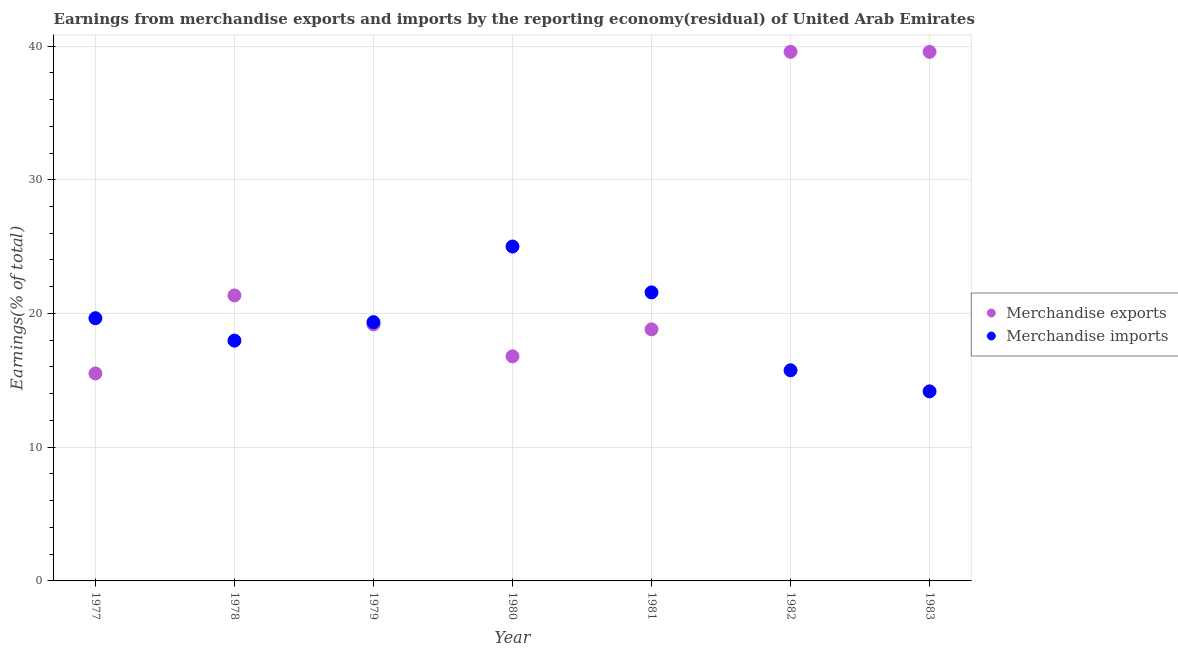How many different coloured dotlines are there?
Give a very brief answer. 2. What is the earnings from merchandise exports in 1981?
Make the answer very short. 18.81. Across all years, what is the maximum earnings from merchandise exports?
Offer a very short reply. 39.56. Across all years, what is the minimum earnings from merchandise exports?
Your answer should be compact. 15.52. In which year was the earnings from merchandise exports maximum?
Your answer should be very brief. 1982. In which year was the earnings from merchandise exports minimum?
Your answer should be very brief. 1977. What is the total earnings from merchandise imports in the graph?
Your answer should be very brief. 133.48. What is the difference between the earnings from merchandise imports in 1978 and that in 1983?
Your response must be concise. 3.79. What is the difference between the earnings from merchandise imports in 1982 and the earnings from merchandise exports in 1983?
Your answer should be very brief. -23.81. What is the average earnings from merchandise imports per year?
Make the answer very short. 19.07. In the year 1982, what is the difference between the earnings from merchandise exports and earnings from merchandise imports?
Your answer should be compact. 23.81. In how many years, is the earnings from merchandise imports greater than 20 %?
Offer a very short reply. 2. What is the ratio of the earnings from merchandise imports in 1978 to that in 1981?
Make the answer very short. 0.83. What is the difference between the highest and the second highest earnings from merchandise imports?
Your response must be concise. 3.43. What is the difference between the highest and the lowest earnings from merchandise exports?
Your response must be concise. 24.05. In how many years, is the earnings from merchandise exports greater than the average earnings from merchandise exports taken over all years?
Offer a very short reply. 2. Is the sum of the earnings from merchandise imports in 1977 and 1980 greater than the maximum earnings from merchandise exports across all years?
Offer a very short reply. Yes. Does the earnings from merchandise imports monotonically increase over the years?
Your answer should be very brief. No. How many years are there in the graph?
Your answer should be compact. 7. What is the difference between two consecutive major ticks on the Y-axis?
Offer a terse response. 10. Does the graph contain grids?
Provide a succinct answer. Yes. What is the title of the graph?
Offer a very short reply. Earnings from merchandise exports and imports by the reporting economy(residual) of United Arab Emirates. What is the label or title of the Y-axis?
Offer a terse response. Earnings(% of total). What is the Earnings(% of total) of Merchandise exports in 1977?
Keep it short and to the point. 15.52. What is the Earnings(% of total) of Merchandise imports in 1977?
Ensure brevity in your answer.  19.65. What is the Earnings(% of total) of Merchandise exports in 1978?
Make the answer very short. 21.35. What is the Earnings(% of total) in Merchandise imports in 1978?
Give a very brief answer. 17.97. What is the Earnings(% of total) of Merchandise exports in 1979?
Offer a terse response. 19.18. What is the Earnings(% of total) in Merchandise imports in 1979?
Provide a succinct answer. 19.35. What is the Earnings(% of total) in Merchandise exports in 1980?
Your answer should be very brief. 16.79. What is the Earnings(% of total) of Merchandise imports in 1980?
Keep it short and to the point. 25.01. What is the Earnings(% of total) of Merchandise exports in 1981?
Your response must be concise. 18.81. What is the Earnings(% of total) of Merchandise imports in 1981?
Offer a terse response. 21.58. What is the Earnings(% of total) of Merchandise exports in 1982?
Offer a very short reply. 39.56. What is the Earnings(% of total) in Merchandise imports in 1982?
Offer a terse response. 15.75. What is the Earnings(% of total) in Merchandise exports in 1983?
Provide a succinct answer. 39.56. What is the Earnings(% of total) in Merchandise imports in 1983?
Provide a short and direct response. 14.18. Across all years, what is the maximum Earnings(% of total) of Merchandise exports?
Provide a succinct answer. 39.56. Across all years, what is the maximum Earnings(% of total) in Merchandise imports?
Your response must be concise. 25.01. Across all years, what is the minimum Earnings(% of total) of Merchandise exports?
Give a very brief answer. 15.52. Across all years, what is the minimum Earnings(% of total) in Merchandise imports?
Offer a very short reply. 14.18. What is the total Earnings(% of total) in Merchandise exports in the graph?
Offer a terse response. 170.78. What is the total Earnings(% of total) of Merchandise imports in the graph?
Ensure brevity in your answer.  133.48. What is the difference between the Earnings(% of total) of Merchandise exports in 1977 and that in 1978?
Make the answer very short. -5.83. What is the difference between the Earnings(% of total) in Merchandise imports in 1977 and that in 1978?
Offer a terse response. 1.68. What is the difference between the Earnings(% of total) of Merchandise exports in 1977 and that in 1979?
Offer a very short reply. -3.67. What is the difference between the Earnings(% of total) in Merchandise imports in 1977 and that in 1979?
Make the answer very short. 0.29. What is the difference between the Earnings(% of total) of Merchandise exports in 1977 and that in 1980?
Your answer should be compact. -1.28. What is the difference between the Earnings(% of total) in Merchandise imports in 1977 and that in 1980?
Keep it short and to the point. -5.36. What is the difference between the Earnings(% of total) in Merchandise exports in 1977 and that in 1981?
Offer a terse response. -3.3. What is the difference between the Earnings(% of total) in Merchandise imports in 1977 and that in 1981?
Offer a very short reply. -1.93. What is the difference between the Earnings(% of total) of Merchandise exports in 1977 and that in 1982?
Give a very brief answer. -24.05. What is the difference between the Earnings(% of total) of Merchandise imports in 1977 and that in 1982?
Offer a very short reply. 3.89. What is the difference between the Earnings(% of total) in Merchandise exports in 1977 and that in 1983?
Your response must be concise. -24.05. What is the difference between the Earnings(% of total) in Merchandise imports in 1977 and that in 1983?
Offer a very short reply. 5.47. What is the difference between the Earnings(% of total) in Merchandise exports in 1978 and that in 1979?
Your answer should be very brief. 2.17. What is the difference between the Earnings(% of total) in Merchandise imports in 1978 and that in 1979?
Provide a short and direct response. -1.38. What is the difference between the Earnings(% of total) in Merchandise exports in 1978 and that in 1980?
Ensure brevity in your answer.  4.55. What is the difference between the Earnings(% of total) of Merchandise imports in 1978 and that in 1980?
Your answer should be compact. -7.04. What is the difference between the Earnings(% of total) of Merchandise exports in 1978 and that in 1981?
Provide a succinct answer. 2.53. What is the difference between the Earnings(% of total) in Merchandise imports in 1978 and that in 1981?
Ensure brevity in your answer.  -3.61. What is the difference between the Earnings(% of total) of Merchandise exports in 1978 and that in 1982?
Offer a very short reply. -18.22. What is the difference between the Earnings(% of total) of Merchandise imports in 1978 and that in 1982?
Ensure brevity in your answer.  2.22. What is the difference between the Earnings(% of total) of Merchandise exports in 1978 and that in 1983?
Your response must be concise. -18.22. What is the difference between the Earnings(% of total) of Merchandise imports in 1978 and that in 1983?
Make the answer very short. 3.79. What is the difference between the Earnings(% of total) in Merchandise exports in 1979 and that in 1980?
Make the answer very short. 2.39. What is the difference between the Earnings(% of total) of Merchandise imports in 1979 and that in 1980?
Provide a short and direct response. -5.65. What is the difference between the Earnings(% of total) in Merchandise exports in 1979 and that in 1981?
Your answer should be compact. 0.37. What is the difference between the Earnings(% of total) of Merchandise imports in 1979 and that in 1981?
Your answer should be compact. -2.23. What is the difference between the Earnings(% of total) in Merchandise exports in 1979 and that in 1982?
Ensure brevity in your answer.  -20.38. What is the difference between the Earnings(% of total) in Merchandise imports in 1979 and that in 1982?
Provide a short and direct response. 3.6. What is the difference between the Earnings(% of total) of Merchandise exports in 1979 and that in 1983?
Give a very brief answer. -20.38. What is the difference between the Earnings(% of total) in Merchandise imports in 1979 and that in 1983?
Make the answer very short. 5.18. What is the difference between the Earnings(% of total) of Merchandise exports in 1980 and that in 1981?
Your answer should be compact. -2.02. What is the difference between the Earnings(% of total) of Merchandise imports in 1980 and that in 1981?
Your answer should be compact. 3.43. What is the difference between the Earnings(% of total) in Merchandise exports in 1980 and that in 1982?
Ensure brevity in your answer.  -22.77. What is the difference between the Earnings(% of total) in Merchandise imports in 1980 and that in 1982?
Keep it short and to the point. 9.25. What is the difference between the Earnings(% of total) of Merchandise exports in 1980 and that in 1983?
Provide a succinct answer. -22.77. What is the difference between the Earnings(% of total) in Merchandise imports in 1980 and that in 1983?
Offer a terse response. 10.83. What is the difference between the Earnings(% of total) in Merchandise exports in 1981 and that in 1982?
Offer a terse response. -20.75. What is the difference between the Earnings(% of total) in Merchandise imports in 1981 and that in 1982?
Make the answer very short. 5.83. What is the difference between the Earnings(% of total) of Merchandise exports in 1981 and that in 1983?
Ensure brevity in your answer.  -20.75. What is the difference between the Earnings(% of total) of Merchandise imports in 1981 and that in 1983?
Ensure brevity in your answer.  7.4. What is the difference between the Earnings(% of total) in Merchandise exports in 1982 and that in 1983?
Offer a very short reply. 0. What is the difference between the Earnings(% of total) of Merchandise imports in 1982 and that in 1983?
Offer a terse response. 1.58. What is the difference between the Earnings(% of total) in Merchandise exports in 1977 and the Earnings(% of total) in Merchandise imports in 1978?
Offer a very short reply. -2.46. What is the difference between the Earnings(% of total) of Merchandise exports in 1977 and the Earnings(% of total) of Merchandise imports in 1979?
Your answer should be compact. -3.84. What is the difference between the Earnings(% of total) of Merchandise exports in 1977 and the Earnings(% of total) of Merchandise imports in 1980?
Offer a very short reply. -9.49. What is the difference between the Earnings(% of total) of Merchandise exports in 1977 and the Earnings(% of total) of Merchandise imports in 1981?
Offer a very short reply. -6.06. What is the difference between the Earnings(% of total) in Merchandise exports in 1977 and the Earnings(% of total) in Merchandise imports in 1982?
Provide a succinct answer. -0.24. What is the difference between the Earnings(% of total) in Merchandise exports in 1977 and the Earnings(% of total) in Merchandise imports in 1983?
Give a very brief answer. 1.34. What is the difference between the Earnings(% of total) in Merchandise exports in 1978 and the Earnings(% of total) in Merchandise imports in 1979?
Offer a very short reply. 2. What is the difference between the Earnings(% of total) of Merchandise exports in 1978 and the Earnings(% of total) of Merchandise imports in 1980?
Give a very brief answer. -3.66. What is the difference between the Earnings(% of total) of Merchandise exports in 1978 and the Earnings(% of total) of Merchandise imports in 1981?
Ensure brevity in your answer.  -0.23. What is the difference between the Earnings(% of total) in Merchandise exports in 1978 and the Earnings(% of total) in Merchandise imports in 1982?
Provide a short and direct response. 5.6. What is the difference between the Earnings(% of total) of Merchandise exports in 1978 and the Earnings(% of total) of Merchandise imports in 1983?
Offer a very short reply. 7.17. What is the difference between the Earnings(% of total) of Merchandise exports in 1979 and the Earnings(% of total) of Merchandise imports in 1980?
Ensure brevity in your answer.  -5.82. What is the difference between the Earnings(% of total) in Merchandise exports in 1979 and the Earnings(% of total) in Merchandise imports in 1981?
Your response must be concise. -2.39. What is the difference between the Earnings(% of total) in Merchandise exports in 1979 and the Earnings(% of total) in Merchandise imports in 1982?
Offer a very short reply. 3.43. What is the difference between the Earnings(% of total) in Merchandise exports in 1979 and the Earnings(% of total) in Merchandise imports in 1983?
Provide a succinct answer. 5.01. What is the difference between the Earnings(% of total) of Merchandise exports in 1980 and the Earnings(% of total) of Merchandise imports in 1981?
Provide a short and direct response. -4.78. What is the difference between the Earnings(% of total) in Merchandise exports in 1980 and the Earnings(% of total) in Merchandise imports in 1982?
Keep it short and to the point. 1.04. What is the difference between the Earnings(% of total) in Merchandise exports in 1980 and the Earnings(% of total) in Merchandise imports in 1983?
Make the answer very short. 2.62. What is the difference between the Earnings(% of total) in Merchandise exports in 1981 and the Earnings(% of total) in Merchandise imports in 1982?
Keep it short and to the point. 3.06. What is the difference between the Earnings(% of total) of Merchandise exports in 1981 and the Earnings(% of total) of Merchandise imports in 1983?
Your response must be concise. 4.64. What is the difference between the Earnings(% of total) in Merchandise exports in 1982 and the Earnings(% of total) in Merchandise imports in 1983?
Your response must be concise. 25.39. What is the average Earnings(% of total) in Merchandise exports per year?
Make the answer very short. 24.4. What is the average Earnings(% of total) in Merchandise imports per year?
Provide a succinct answer. 19.07. In the year 1977, what is the difference between the Earnings(% of total) in Merchandise exports and Earnings(% of total) in Merchandise imports?
Your answer should be compact. -4.13. In the year 1978, what is the difference between the Earnings(% of total) of Merchandise exports and Earnings(% of total) of Merchandise imports?
Provide a short and direct response. 3.38. In the year 1979, what is the difference between the Earnings(% of total) of Merchandise exports and Earnings(% of total) of Merchandise imports?
Offer a terse response. -0.17. In the year 1980, what is the difference between the Earnings(% of total) in Merchandise exports and Earnings(% of total) in Merchandise imports?
Offer a very short reply. -8.21. In the year 1981, what is the difference between the Earnings(% of total) in Merchandise exports and Earnings(% of total) in Merchandise imports?
Offer a very short reply. -2.76. In the year 1982, what is the difference between the Earnings(% of total) of Merchandise exports and Earnings(% of total) of Merchandise imports?
Ensure brevity in your answer.  23.81. In the year 1983, what is the difference between the Earnings(% of total) in Merchandise exports and Earnings(% of total) in Merchandise imports?
Give a very brief answer. 25.39. What is the ratio of the Earnings(% of total) in Merchandise exports in 1977 to that in 1978?
Offer a terse response. 0.73. What is the ratio of the Earnings(% of total) in Merchandise imports in 1977 to that in 1978?
Provide a short and direct response. 1.09. What is the ratio of the Earnings(% of total) in Merchandise exports in 1977 to that in 1979?
Your answer should be very brief. 0.81. What is the ratio of the Earnings(% of total) in Merchandise imports in 1977 to that in 1979?
Offer a terse response. 1.02. What is the ratio of the Earnings(% of total) of Merchandise exports in 1977 to that in 1980?
Ensure brevity in your answer.  0.92. What is the ratio of the Earnings(% of total) in Merchandise imports in 1977 to that in 1980?
Keep it short and to the point. 0.79. What is the ratio of the Earnings(% of total) in Merchandise exports in 1977 to that in 1981?
Give a very brief answer. 0.82. What is the ratio of the Earnings(% of total) in Merchandise imports in 1977 to that in 1981?
Offer a very short reply. 0.91. What is the ratio of the Earnings(% of total) in Merchandise exports in 1977 to that in 1982?
Offer a terse response. 0.39. What is the ratio of the Earnings(% of total) of Merchandise imports in 1977 to that in 1982?
Ensure brevity in your answer.  1.25. What is the ratio of the Earnings(% of total) in Merchandise exports in 1977 to that in 1983?
Make the answer very short. 0.39. What is the ratio of the Earnings(% of total) in Merchandise imports in 1977 to that in 1983?
Offer a very short reply. 1.39. What is the ratio of the Earnings(% of total) of Merchandise exports in 1978 to that in 1979?
Offer a terse response. 1.11. What is the ratio of the Earnings(% of total) in Merchandise exports in 1978 to that in 1980?
Keep it short and to the point. 1.27. What is the ratio of the Earnings(% of total) of Merchandise imports in 1978 to that in 1980?
Give a very brief answer. 0.72. What is the ratio of the Earnings(% of total) in Merchandise exports in 1978 to that in 1981?
Keep it short and to the point. 1.13. What is the ratio of the Earnings(% of total) of Merchandise imports in 1978 to that in 1981?
Offer a very short reply. 0.83. What is the ratio of the Earnings(% of total) in Merchandise exports in 1978 to that in 1982?
Your answer should be very brief. 0.54. What is the ratio of the Earnings(% of total) of Merchandise imports in 1978 to that in 1982?
Offer a terse response. 1.14. What is the ratio of the Earnings(% of total) of Merchandise exports in 1978 to that in 1983?
Offer a very short reply. 0.54. What is the ratio of the Earnings(% of total) of Merchandise imports in 1978 to that in 1983?
Offer a terse response. 1.27. What is the ratio of the Earnings(% of total) in Merchandise exports in 1979 to that in 1980?
Offer a very short reply. 1.14. What is the ratio of the Earnings(% of total) in Merchandise imports in 1979 to that in 1980?
Provide a succinct answer. 0.77. What is the ratio of the Earnings(% of total) in Merchandise exports in 1979 to that in 1981?
Provide a succinct answer. 1.02. What is the ratio of the Earnings(% of total) in Merchandise imports in 1979 to that in 1981?
Ensure brevity in your answer.  0.9. What is the ratio of the Earnings(% of total) in Merchandise exports in 1979 to that in 1982?
Offer a terse response. 0.48. What is the ratio of the Earnings(% of total) of Merchandise imports in 1979 to that in 1982?
Ensure brevity in your answer.  1.23. What is the ratio of the Earnings(% of total) of Merchandise exports in 1979 to that in 1983?
Make the answer very short. 0.48. What is the ratio of the Earnings(% of total) of Merchandise imports in 1979 to that in 1983?
Your answer should be very brief. 1.37. What is the ratio of the Earnings(% of total) of Merchandise exports in 1980 to that in 1981?
Provide a short and direct response. 0.89. What is the ratio of the Earnings(% of total) in Merchandise imports in 1980 to that in 1981?
Your answer should be very brief. 1.16. What is the ratio of the Earnings(% of total) of Merchandise exports in 1980 to that in 1982?
Provide a succinct answer. 0.42. What is the ratio of the Earnings(% of total) in Merchandise imports in 1980 to that in 1982?
Make the answer very short. 1.59. What is the ratio of the Earnings(% of total) of Merchandise exports in 1980 to that in 1983?
Keep it short and to the point. 0.42. What is the ratio of the Earnings(% of total) in Merchandise imports in 1980 to that in 1983?
Make the answer very short. 1.76. What is the ratio of the Earnings(% of total) in Merchandise exports in 1981 to that in 1982?
Provide a succinct answer. 0.48. What is the ratio of the Earnings(% of total) of Merchandise imports in 1981 to that in 1982?
Offer a terse response. 1.37. What is the ratio of the Earnings(% of total) in Merchandise exports in 1981 to that in 1983?
Give a very brief answer. 0.48. What is the ratio of the Earnings(% of total) in Merchandise imports in 1981 to that in 1983?
Give a very brief answer. 1.52. What is the ratio of the Earnings(% of total) of Merchandise imports in 1982 to that in 1983?
Offer a terse response. 1.11. What is the difference between the highest and the second highest Earnings(% of total) of Merchandise exports?
Provide a short and direct response. 0. What is the difference between the highest and the second highest Earnings(% of total) in Merchandise imports?
Make the answer very short. 3.43. What is the difference between the highest and the lowest Earnings(% of total) in Merchandise exports?
Offer a terse response. 24.05. What is the difference between the highest and the lowest Earnings(% of total) of Merchandise imports?
Offer a very short reply. 10.83. 